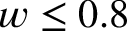<formula> <loc_0><loc_0><loc_500><loc_500>w \leq 0 . 8</formula> 